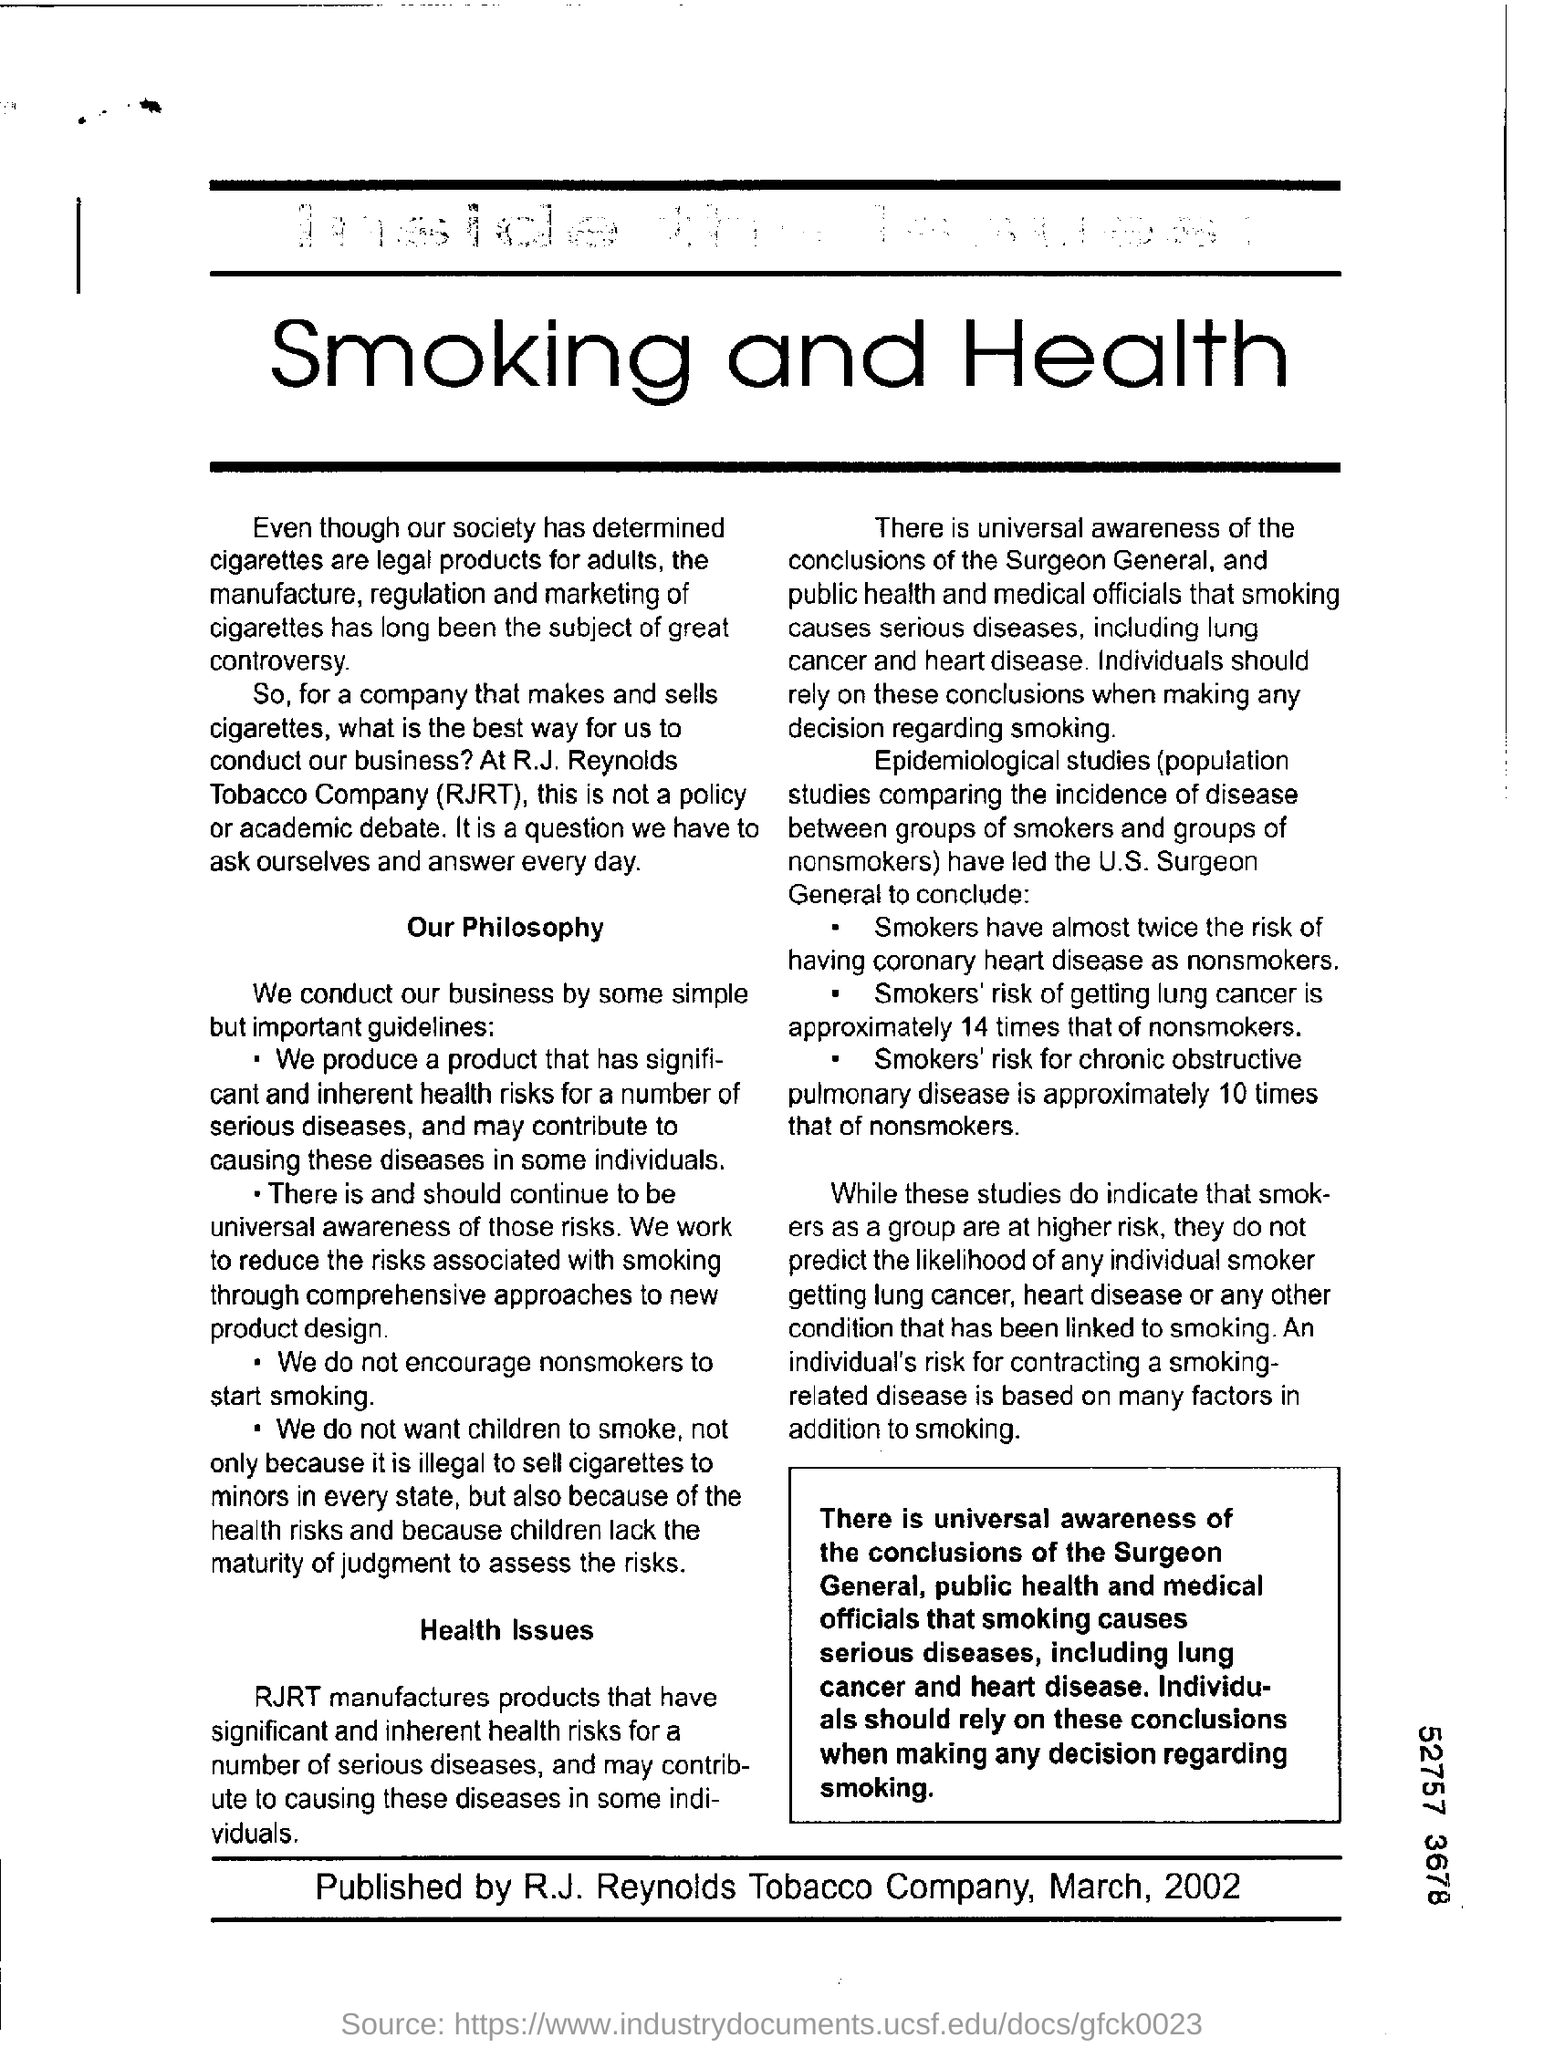What is the heading of the page ?
Make the answer very short. Smoking and Health. 